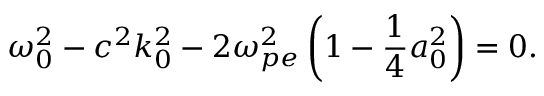<formula> <loc_0><loc_0><loc_500><loc_500>\omega _ { 0 } ^ { 2 } - c ^ { 2 } k _ { 0 } ^ { 2 } - 2 \omega _ { p e } ^ { 2 } \left ( 1 - \frac { 1 } { 4 } a _ { 0 } ^ { 2 } \right ) = 0 .</formula> 